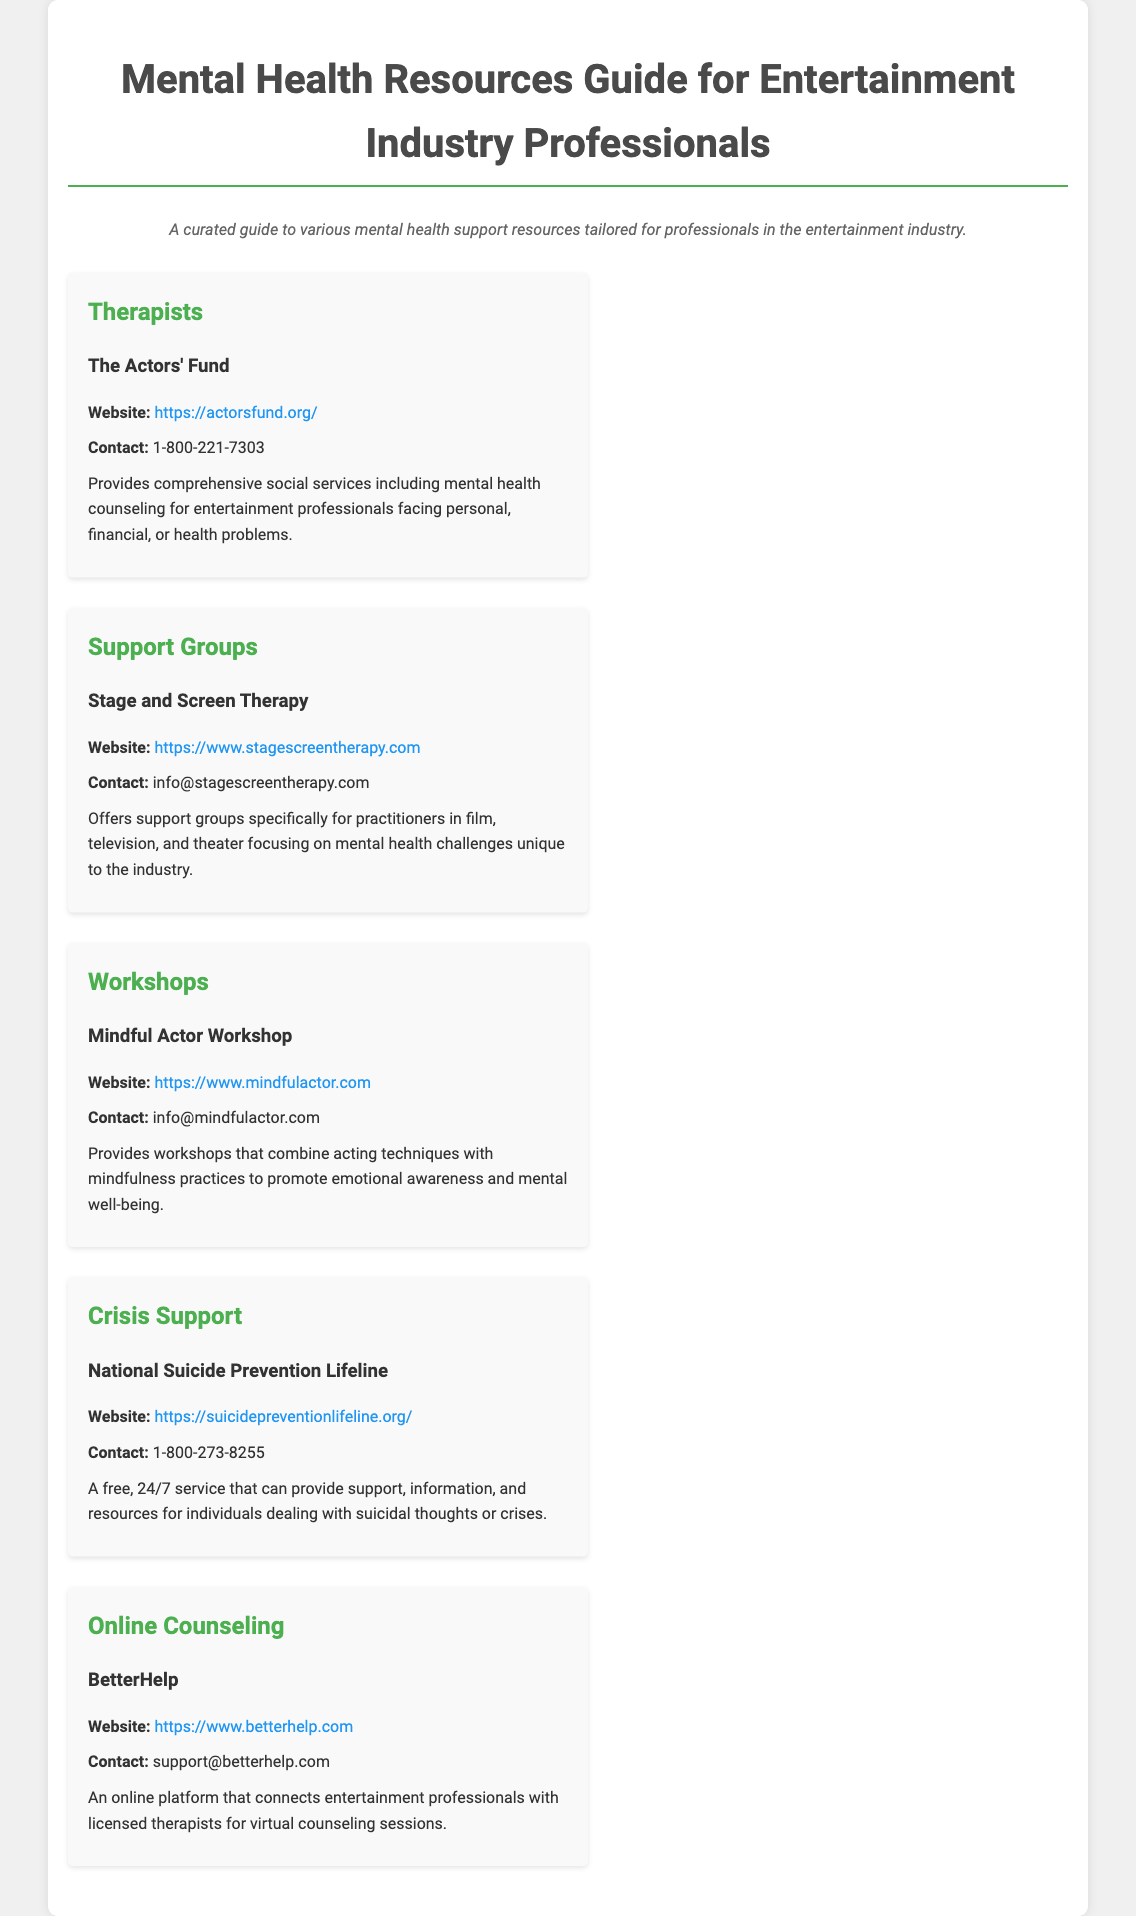What organization provides mental health counseling for entertainment professionals? The document mentions The Actors' Fund as an organization that provides mental health counseling for entertainment professionals.
Answer: The Actors' Fund What is the contact number for the National Suicide Prevention Lifeline? The document lists 1-800-273-8255 as the contact number for the National Suicide Prevention Lifeline.
Answer: 1-800-273-8255 Which website can you visit for online counseling services? The document provides BetterHelp's website as a resource for online counseling services.
Answer: https://www.betterhelp.com What type of support does Stage and Screen Therapy provide? The document indicates that Stage and Screen Therapy offers support groups focusing on mental health challenges unique to the entertainment industry.
Answer: Support groups What is the main focus of the Mindful Actor Workshop? The document states that the Mindful Actor Workshop combines acting techniques with mindfulness practices to promote mental well-being.
Answer: Mindfulness practices What is the purpose of the resources listed in the document? The resources listed are tailored to provide mental health support for professionals in the entertainment industry.
Answer: Mental health support How often is the National Suicide Prevention Lifeline available? The document specifies that it is a free, 24/7 service.
Answer: 24/7 Who can be contacted at info@stagescreentherapy.com? This email address is for contacting Stage and Screen Therapy, which offers support groups.
Answer: Stage and Screen Therapy What does BetterHelp offer to entertainment professionals? The document mentions that BetterHelp connects entertainment professionals with licensed therapists for virtual counseling sessions.
Answer: Virtual counseling sessions 